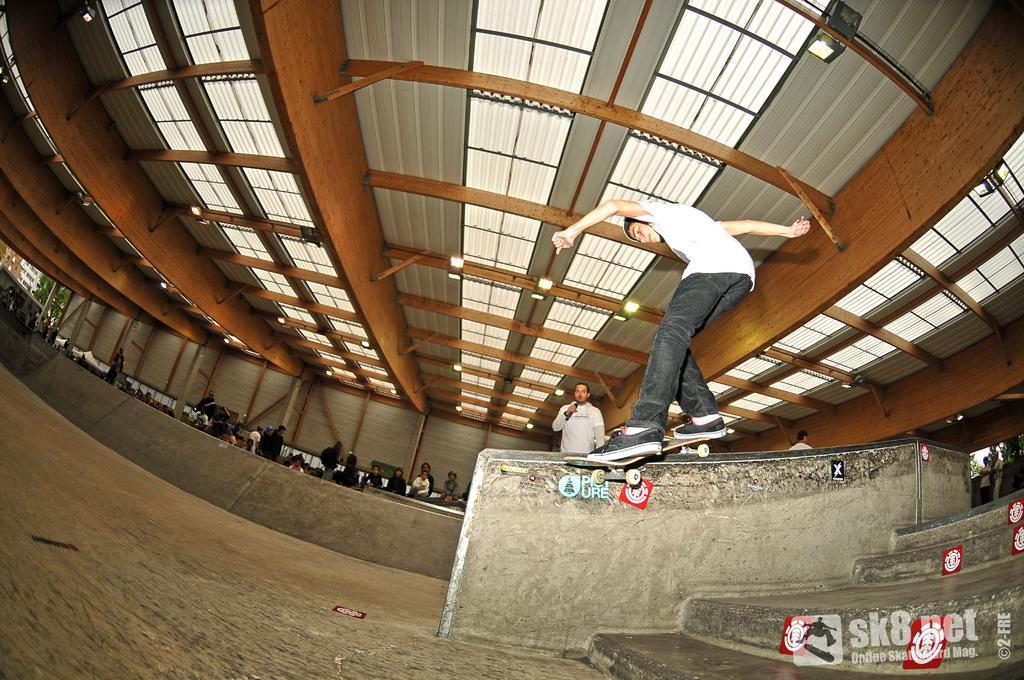Can you describe this image briefly? In the center of the image we can see a person skating on the ramp. In the background there are people. At the top there are lights. On the right we can see stairs. 